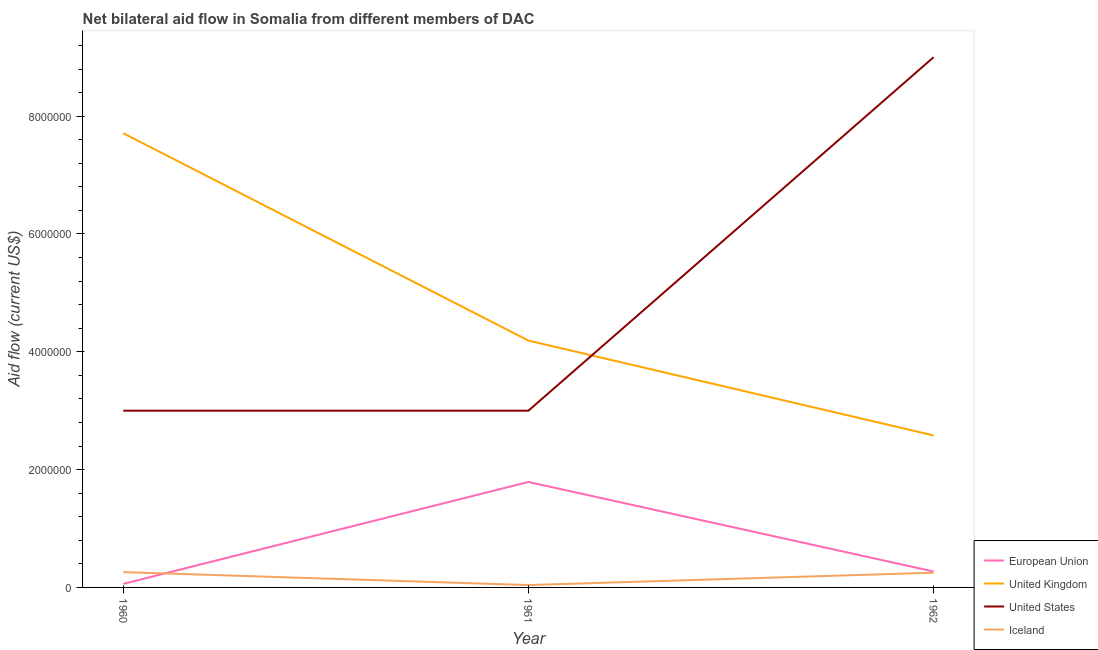How many different coloured lines are there?
Offer a very short reply. 4. Does the line corresponding to amount of aid given by us intersect with the line corresponding to amount of aid given by uk?
Make the answer very short. Yes. What is the amount of aid given by iceland in 1962?
Make the answer very short. 2.50e+05. Across all years, what is the maximum amount of aid given by iceland?
Provide a short and direct response. 2.60e+05. Across all years, what is the minimum amount of aid given by uk?
Provide a succinct answer. 2.58e+06. What is the total amount of aid given by us in the graph?
Your response must be concise. 1.50e+07. What is the difference between the amount of aid given by uk in 1960 and that in 1961?
Offer a very short reply. 3.52e+06. What is the difference between the amount of aid given by eu in 1960 and the amount of aid given by us in 1961?
Your response must be concise. -2.94e+06. What is the average amount of aid given by eu per year?
Offer a very short reply. 7.07e+05. In the year 1961, what is the difference between the amount of aid given by iceland and amount of aid given by us?
Your answer should be compact. -2.96e+06. What is the ratio of the amount of aid given by iceland in 1961 to that in 1962?
Your response must be concise. 0.16. What is the difference between the highest and the second highest amount of aid given by uk?
Keep it short and to the point. 3.52e+06. What is the difference between the highest and the lowest amount of aid given by us?
Your answer should be very brief. 6.00e+06. In how many years, is the amount of aid given by us greater than the average amount of aid given by us taken over all years?
Your response must be concise. 1. Is the sum of the amount of aid given by eu in 1960 and 1961 greater than the maximum amount of aid given by uk across all years?
Your response must be concise. No. Is it the case that in every year, the sum of the amount of aid given by eu and amount of aid given by uk is greater than the amount of aid given by us?
Give a very brief answer. No. Is the amount of aid given by us strictly greater than the amount of aid given by eu over the years?
Your answer should be compact. Yes. Is the amount of aid given by us strictly less than the amount of aid given by uk over the years?
Ensure brevity in your answer.  No. How many lines are there?
Your answer should be very brief. 4. How many years are there in the graph?
Offer a very short reply. 3. What is the difference between two consecutive major ticks on the Y-axis?
Keep it short and to the point. 2.00e+06. Are the values on the major ticks of Y-axis written in scientific E-notation?
Provide a succinct answer. No. Where does the legend appear in the graph?
Make the answer very short. Bottom right. How are the legend labels stacked?
Offer a terse response. Vertical. What is the title of the graph?
Your response must be concise. Net bilateral aid flow in Somalia from different members of DAC. What is the Aid flow (current US$) in United Kingdom in 1960?
Your response must be concise. 7.71e+06. What is the Aid flow (current US$) of European Union in 1961?
Provide a short and direct response. 1.79e+06. What is the Aid flow (current US$) in United Kingdom in 1961?
Provide a short and direct response. 4.19e+06. What is the Aid flow (current US$) in United States in 1961?
Offer a very short reply. 3.00e+06. What is the Aid flow (current US$) in European Union in 1962?
Offer a very short reply. 2.70e+05. What is the Aid flow (current US$) in United Kingdom in 1962?
Ensure brevity in your answer.  2.58e+06. What is the Aid flow (current US$) in United States in 1962?
Make the answer very short. 9.00e+06. Across all years, what is the maximum Aid flow (current US$) in European Union?
Your answer should be very brief. 1.79e+06. Across all years, what is the maximum Aid flow (current US$) of United Kingdom?
Give a very brief answer. 7.71e+06. Across all years, what is the maximum Aid flow (current US$) in United States?
Offer a very short reply. 9.00e+06. Across all years, what is the maximum Aid flow (current US$) in Iceland?
Ensure brevity in your answer.  2.60e+05. Across all years, what is the minimum Aid flow (current US$) in European Union?
Offer a very short reply. 6.00e+04. Across all years, what is the minimum Aid flow (current US$) in United Kingdom?
Provide a short and direct response. 2.58e+06. Across all years, what is the minimum Aid flow (current US$) of United States?
Keep it short and to the point. 3.00e+06. What is the total Aid flow (current US$) in European Union in the graph?
Provide a succinct answer. 2.12e+06. What is the total Aid flow (current US$) of United Kingdom in the graph?
Provide a succinct answer. 1.45e+07. What is the total Aid flow (current US$) of United States in the graph?
Keep it short and to the point. 1.50e+07. What is the difference between the Aid flow (current US$) in European Union in 1960 and that in 1961?
Offer a very short reply. -1.73e+06. What is the difference between the Aid flow (current US$) of United Kingdom in 1960 and that in 1961?
Offer a very short reply. 3.52e+06. What is the difference between the Aid flow (current US$) in European Union in 1960 and that in 1962?
Offer a very short reply. -2.10e+05. What is the difference between the Aid flow (current US$) of United Kingdom in 1960 and that in 1962?
Provide a short and direct response. 5.13e+06. What is the difference between the Aid flow (current US$) in United States in 1960 and that in 1962?
Ensure brevity in your answer.  -6.00e+06. What is the difference between the Aid flow (current US$) of Iceland in 1960 and that in 1962?
Make the answer very short. 10000. What is the difference between the Aid flow (current US$) in European Union in 1961 and that in 1962?
Offer a terse response. 1.52e+06. What is the difference between the Aid flow (current US$) in United Kingdom in 1961 and that in 1962?
Provide a succinct answer. 1.61e+06. What is the difference between the Aid flow (current US$) of United States in 1961 and that in 1962?
Ensure brevity in your answer.  -6.00e+06. What is the difference between the Aid flow (current US$) in Iceland in 1961 and that in 1962?
Offer a terse response. -2.10e+05. What is the difference between the Aid flow (current US$) in European Union in 1960 and the Aid flow (current US$) in United Kingdom in 1961?
Offer a very short reply. -4.13e+06. What is the difference between the Aid flow (current US$) of European Union in 1960 and the Aid flow (current US$) of United States in 1961?
Give a very brief answer. -2.94e+06. What is the difference between the Aid flow (current US$) in European Union in 1960 and the Aid flow (current US$) in Iceland in 1961?
Your answer should be very brief. 2.00e+04. What is the difference between the Aid flow (current US$) in United Kingdom in 1960 and the Aid flow (current US$) in United States in 1961?
Your answer should be very brief. 4.71e+06. What is the difference between the Aid flow (current US$) in United Kingdom in 1960 and the Aid flow (current US$) in Iceland in 1961?
Ensure brevity in your answer.  7.67e+06. What is the difference between the Aid flow (current US$) in United States in 1960 and the Aid flow (current US$) in Iceland in 1961?
Your answer should be very brief. 2.96e+06. What is the difference between the Aid flow (current US$) of European Union in 1960 and the Aid flow (current US$) of United Kingdom in 1962?
Offer a terse response. -2.52e+06. What is the difference between the Aid flow (current US$) of European Union in 1960 and the Aid flow (current US$) of United States in 1962?
Give a very brief answer. -8.94e+06. What is the difference between the Aid flow (current US$) in European Union in 1960 and the Aid flow (current US$) in Iceland in 1962?
Your response must be concise. -1.90e+05. What is the difference between the Aid flow (current US$) in United Kingdom in 1960 and the Aid flow (current US$) in United States in 1962?
Provide a succinct answer. -1.29e+06. What is the difference between the Aid flow (current US$) of United Kingdom in 1960 and the Aid flow (current US$) of Iceland in 1962?
Your answer should be compact. 7.46e+06. What is the difference between the Aid flow (current US$) in United States in 1960 and the Aid flow (current US$) in Iceland in 1962?
Offer a very short reply. 2.75e+06. What is the difference between the Aid flow (current US$) in European Union in 1961 and the Aid flow (current US$) in United Kingdom in 1962?
Provide a succinct answer. -7.90e+05. What is the difference between the Aid flow (current US$) of European Union in 1961 and the Aid flow (current US$) of United States in 1962?
Offer a very short reply. -7.21e+06. What is the difference between the Aid flow (current US$) of European Union in 1961 and the Aid flow (current US$) of Iceland in 1962?
Your response must be concise. 1.54e+06. What is the difference between the Aid flow (current US$) of United Kingdom in 1961 and the Aid flow (current US$) of United States in 1962?
Provide a short and direct response. -4.81e+06. What is the difference between the Aid flow (current US$) of United Kingdom in 1961 and the Aid flow (current US$) of Iceland in 1962?
Ensure brevity in your answer.  3.94e+06. What is the difference between the Aid flow (current US$) of United States in 1961 and the Aid flow (current US$) of Iceland in 1962?
Offer a terse response. 2.75e+06. What is the average Aid flow (current US$) of European Union per year?
Give a very brief answer. 7.07e+05. What is the average Aid flow (current US$) of United Kingdom per year?
Make the answer very short. 4.83e+06. What is the average Aid flow (current US$) of United States per year?
Your response must be concise. 5.00e+06. What is the average Aid flow (current US$) in Iceland per year?
Offer a terse response. 1.83e+05. In the year 1960, what is the difference between the Aid flow (current US$) in European Union and Aid flow (current US$) in United Kingdom?
Offer a very short reply. -7.65e+06. In the year 1960, what is the difference between the Aid flow (current US$) of European Union and Aid flow (current US$) of United States?
Ensure brevity in your answer.  -2.94e+06. In the year 1960, what is the difference between the Aid flow (current US$) in United Kingdom and Aid flow (current US$) in United States?
Your answer should be compact. 4.71e+06. In the year 1960, what is the difference between the Aid flow (current US$) in United Kingdom and Aid flow (current US$) in Iceland?
Make the answer very short. 7.45e+06. In the year 1960, what is the difference between the Aid flow (current US$) in United States and Aid flow (current US$) in Iceland?
Your response must be concise. 2.74e+06. In the year 1961, what is the difference between the Aid flow (current US$) of European Union and Aid flow (current US$) of United Kingdom?
Your answer should be very brief. -2.40e+06. In the year 1961, what is the difference between the Aid flow (current US$) in European Union and Aid flow (current US$) in United States?
Your answer should be very brief. -1.21e+06. In the year 1961, what is the difference between the Aid flow (current US$) of European Union and Aid flow (current US$) of Iceland?
Your answer should be compact. 1.75e+06. In the year 1961, what is the difference between the Aid flow (current US$) of United Kingdom and Aid flow (current US$) of United States?
Offer a very short reply. 1.19e+06. In the year 1961, what is the difference between the Aid flow (current US$) of United Kingdom and Aid flow (current US$) of Iceland?
Keep it short and to the point. 4.15e+06. In the year 1961, what is the difference between the Aid flow (current US$) of United States and Aid flow (current US$) of Iceland?
Provide a short and direct response. 2.96e+06. In the year 1962, what is the difference between the Aid flow (current US$) of European Union and Aid flow (current US$) of United Kingdom?
Offer a terse response. -2.31e+06. In the year 1962, what is the difference between the Aid flow (current US$) of European Union and Aid flow (current US$) of United States?
Keep it short and to the point. -8.73e+06. In the year 1962, what is the difference between the Aid flow (current US$) in United Kingdom and Aid flow (current US$) in United States?
Your answer should be compact. -6.42e+06. In the year 1962, what is the difference between the Aid flow (current US$) in United Kingdom and Aid flow (current US$) in Iceland?
Give a very brief answer. 2.33e+06. In the year 1962, what is the difference between the Aid flow (current US$) in United States and Aid flow (current US$) in Iceland?
Ensure brevity in your answer.  8.75e+06. What is the ratio of the Aid flow (current US$) of European Union in 1960 to that in 1961?
Your answer should be compact. 0.03. What is the ratio of the Aid flow (current US$) in United Kingdom in 1960 to that in 1961?
Your response must be concise. 1.84. What is the ratio of the Aid flow (current US$) in United States in 1960 to that in 1961?
Give a very brief answer. 1. What is the ratio of the Aid flow (current US$) in Iceland in 1960 to that in 1961?
Provide a succinct answer. 6.5. What is the ratio of the Aid flow (current US$) of European Union in 1960 to that in 1962?
Give a very brief answer. 0.22. What is the ratio of the Aid flow (current US$) in United Kingdom in 1960 to that in 1962?
Your answer should be very brief. 2.99. What is the ratio of the Aid flow (current US$) in United States in 1960 to that in 1962?
Offer a very short reply. 0.33. What is the ratio of the Aid flow (current US$) of Iceland in 1960 to that in 1962?
Provide a succinct answer. 1.04. What is the ratio of the Aid flow (current US$) of European Union in 1961 to that in 1962?
Your answer should be compact. 6.63. What is the ratio of the Aid flow (current US$) in United Kingdom in 1961 to that in 1962?
Offer a terse response. 1.62. What is the ratio of the Aid flow (current US$) of United States in 1961 to that in 1962?
Give a very brief answer. 0.33. What is the ratio of the Aid flow (current US$) of Iceland in 1961 to that in 1962?
Ensure brevity in your answer.  0.16. What is the difference between the highest and the second highest Aid flow (current US$) in European Union?
Provide a short and direct response. 1.52e+06. What is the difference between the highest and the second highest Aid flow (current US$) of United Kingdom?
Your answer should be very brief. 3.52e+06. What is the difference between the highest and the lowest Aid flow (current US$) in European Union?
Offer a very short reply. 1.73e+06. What is the difference between the highest and the lowest Aid flow (current US$) of United Kingdom?
Provide a succinct answer. 5.13e+06. 